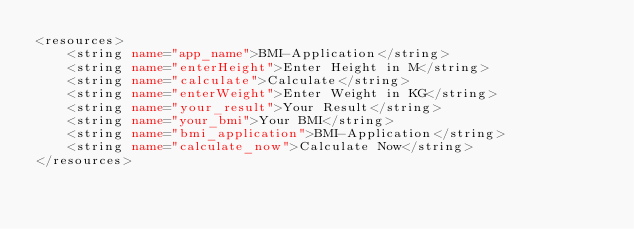<code> <loc_0><loc_0><loc_500><loc_500><_XML_><resources>
    <string name="app_name">BMI-Application</string>
    <string name="enterHeight">Enter Height in M</string>
    <string name="calculate">Calculate</string>
    <string name="enterWeight">Enter Weight in KG</string>
    <string name="your_result">Your Result</string>
    <string name="your_bmi">Your BMI</string>
    <string name="bmi_application">BMI-Application</string>
    <string name="calculate_now">Calculate Now</string>
</resources></code> 